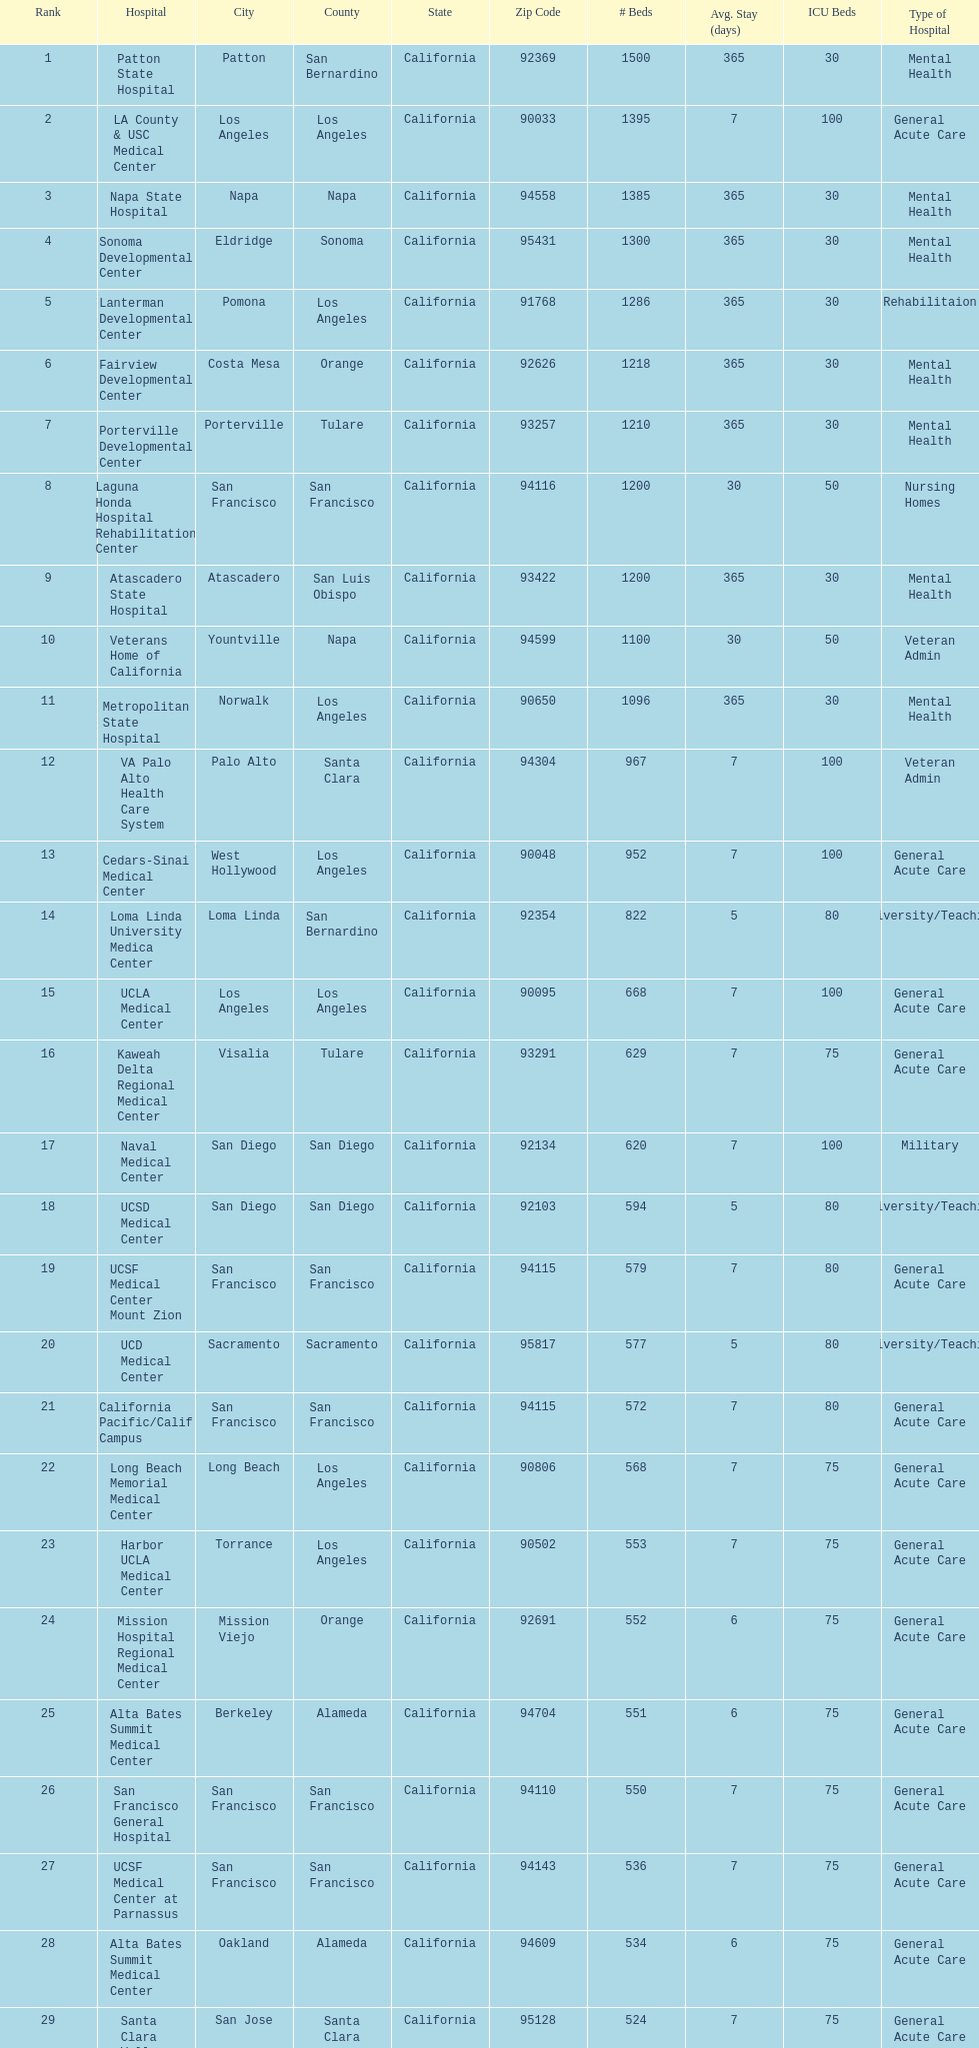How many hospital's have at least 600 beds? 17. 